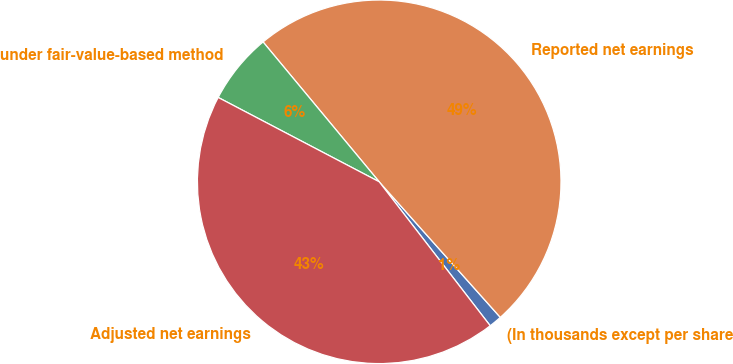<chart> <loc_0><loc_0><loc_500><loc_500><pie_chart><fcel>(In thousands except per share<fcel>Reported net earnings<fcel>under fair-value-based method<fcel>Adjusted net earnings<nl><fcel>1.15%<fcel>49.43%<fcel>6.29%<fcel>43.14%<nl></chart> 